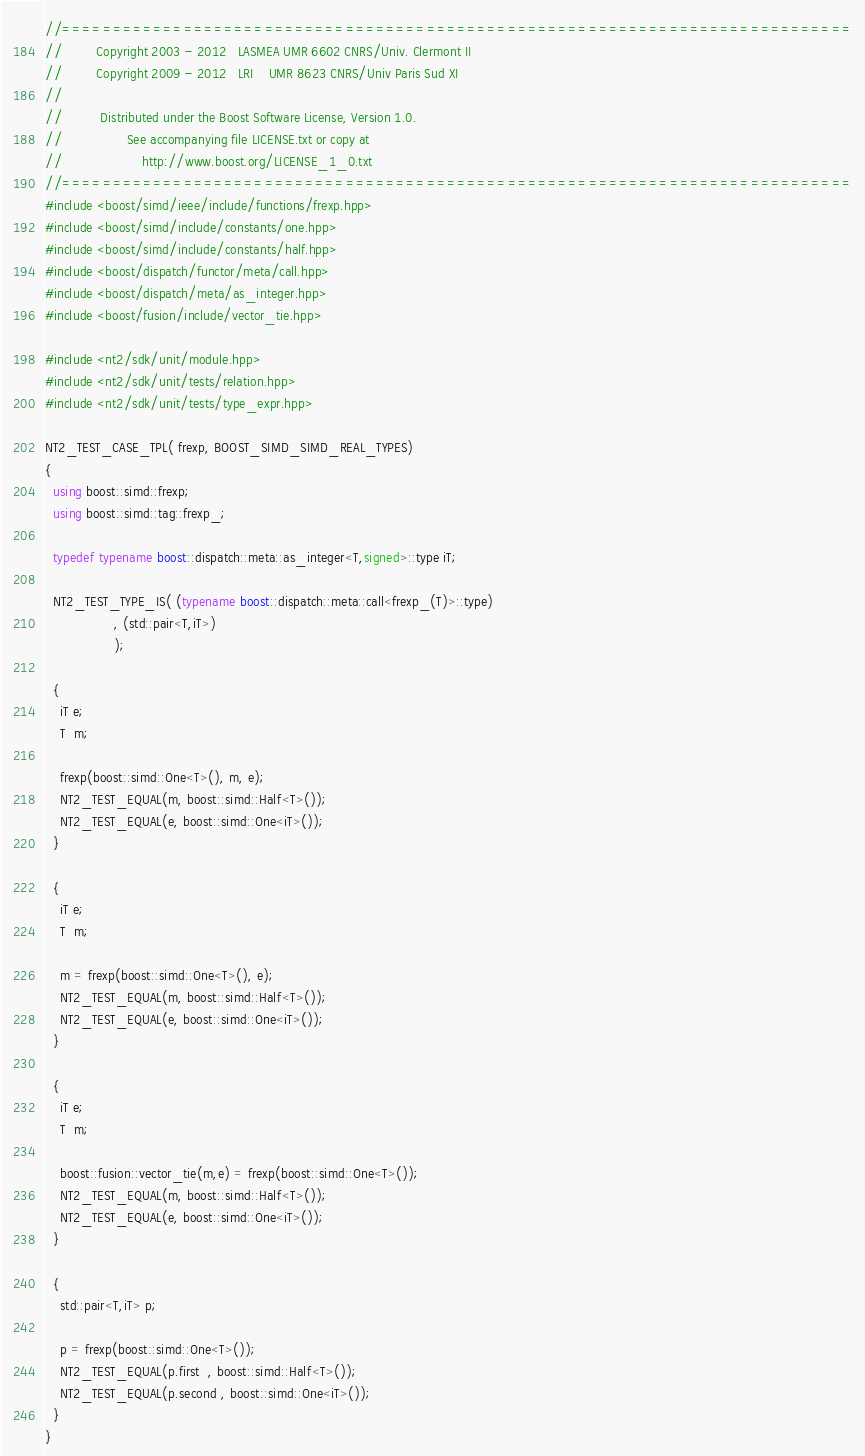Convert code to text. <code><loc_0><loc_0><loc_500><loc_500><_C++_>//==============================================================================
//         Copyright 2003 - 2012   LASMEA UMR 6602 CNRS/Univ. Clermont II
//         Copyright 2009 - 2012   LRI    UMR 8623 CNRS/Univ Paris Sud XI
//
//          Distributed under the Boost Software License, Version 1.0.
//                 See accompanying file LICENSE.txt or copy at
//                     http://www.boost.org/LICENSE_1_0.txt
//==============================================================================
#include <boost/simd/ieee/include/functions/frexp.hpp>
#include <boost/simd/include/constants/one.hpp>
#include <boost/simd/include/constants/half.hpp>
#include <boost/dispatch/functor/meta/call.hpp>
#include <boost/dispatch/meta/as_integer.hpp>
#include <boost/fusion/include/vector_tie.hpp>

#include <nt2/sdk/unit/module.hpp>
#include <nt2/sdk/unit/tests/relation.hpp>
#include <nt2/sdk/unit/tests/type_expr.hpp>

NT2_TEST_CASE_TPL( frexp, BOOST_SIMD_SIMD_REAL_TYPES)
{
  using boost::simd::frexp;
  using boost::simd::tag::frexp_;

  typedef typename boost::dispatch::meta::as_integer<T,signed>::type iT;

  NT2_TEST_TYPE_IS( (typename boost::dispatch::meta::call<frexp_(T)>::type)
                  , (std::pair<T,iT>)
                  );

  {
    iT e;
    T  m;

    frexp(boost::simd::One<T>(), m, e);
    NT2_TEST_EQUAL(m, boost::simd::Half<T>());
    NT2_TEST_EQUAL(e, boost::simd::One<iT>());
  }

  {
    iT e;
    T  m;

    m = frexp(boost::simd::One<T>(), e);
    NT2_TEST_EQUAL(m, boost::simd::Half<T>());
    NT2_TEST_EQUAL(e, boost::simd::One<iT>());
  }

  {
    iT e;
    T  m;

    boost::fusion::vector_tie(m,e) = frexp(boost::simd::One<T>());
    NT2_TEST_EQUAL(m, boost::simd::Half<T>());
    NT2_TEST_EQUAL(e, boost::simd::One<iT>());
  }

  {
    std::pair<T,iT> p;

    p = frexp(boost::simd::One<T>());
    NT2_TEST_EQUAL(p.first  , boost::simd::Half<T>());
    NT2_TEST_EQUAL(p.second , boost::simd::One<iT>());
  }
}
</code> 